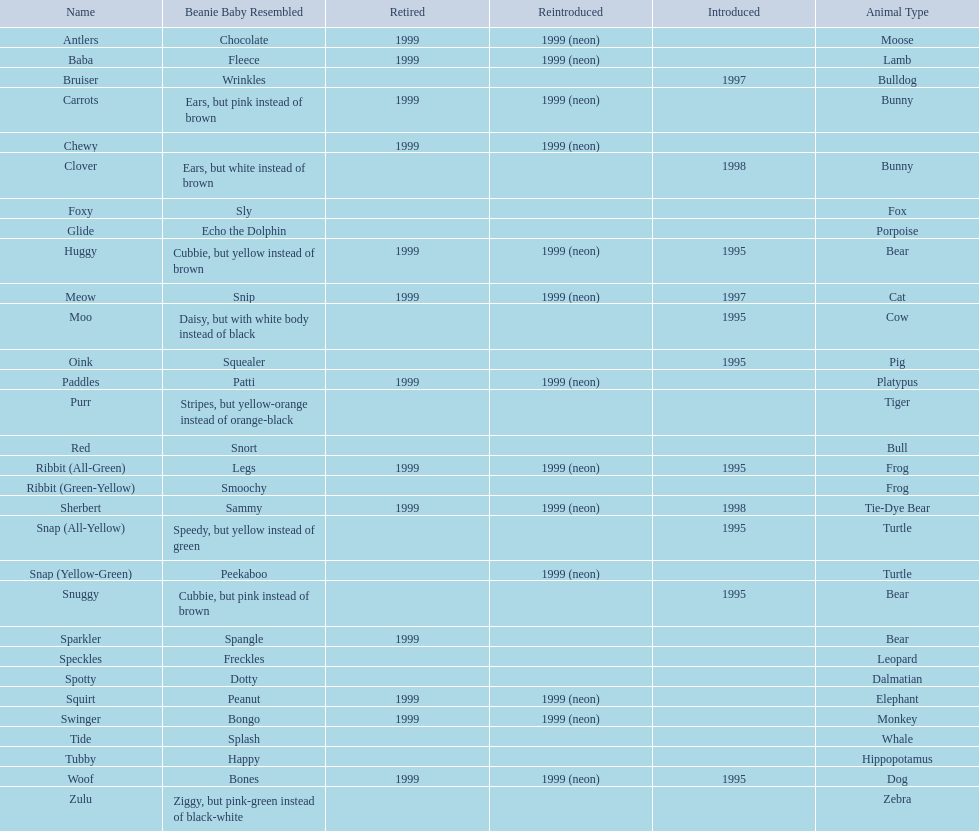What are all the pillow pals? Antlers, Baba, Bruiser, Carrots, Chewy, Clover, Foxy, Glide, Huggy, Meow, Moo, Oink, Paddles, Purr, Red, Ribbit (All-Green), Ribbit (Green-Yellow), Sherbert, Snap (All-Yellow), Snap (Yellow-Green), Snuggy, Sparkler, Speckles, Spotty, Squirt, Swinger, Tide, Tubby, Woof, Zulu. Which is the only without a listed animal type? Chewy. 